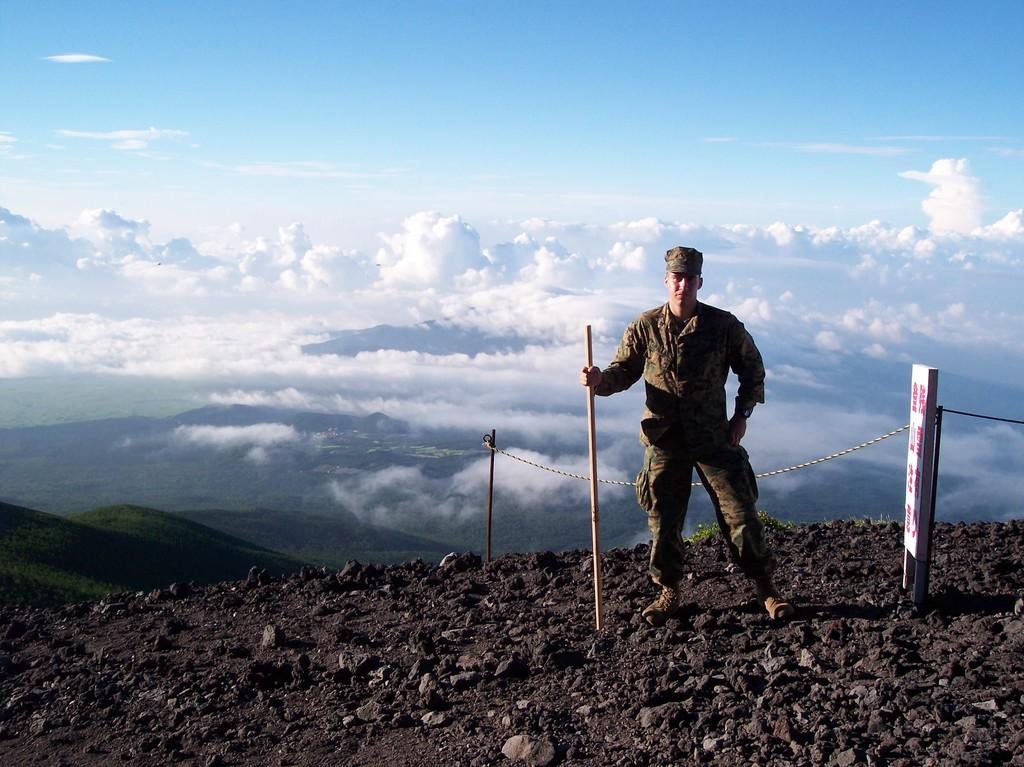What is the main subject of the image? There is a soldier in the image. What is the soldier holding in the image? The soldier is holding a stick. What can be seen behind the soldier? There is a fence behind the soldier. What is visible in the distance in the image? There are mountains in the background of the image. What type of good-bye is the soldier saying in the image? There is no indication in the image that the soldier is saying good-bye or expressing any emotions. 